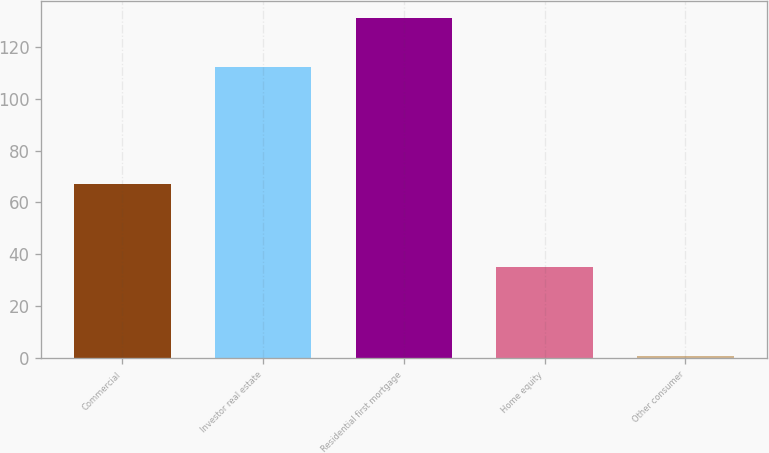<chart> <loc_0><loc_0><loc_500><loc_500><bar_chart><fcel>Commercial<fcel>Investor real estate<fcel>Residential first mortgage<fcel>Home equity<fcel>Other consumer<nl><fcel>67<fcel>112<fcel>131<fcel>35<fcel>1<nl></chart> 